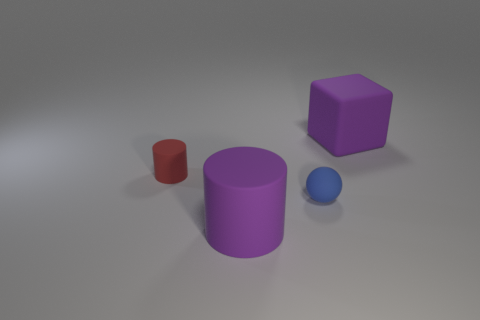Subtract all red cylinders. How many cylinders are left? 1 Subtract all cubes. How many objects are left? 3 Add 2 cylinders. How many objects exist? 6 Subtract all large cubes. Subtract all red rubber objects. How many objects are left? 2 Add 4 purple objects. How many purple objects are left? 6 Add 3 brown cubes. How many brown cubes exist? 3 Subtract 0 blue cylinders. How many objects are left? 4 Subtract 1 spheres. How many spheres are left? 0 Subtract all blue cylinders. Subtract all gray balls. How many cylinders are left? 2 Subtract all cyan balls. How many red blocks are left? 0 